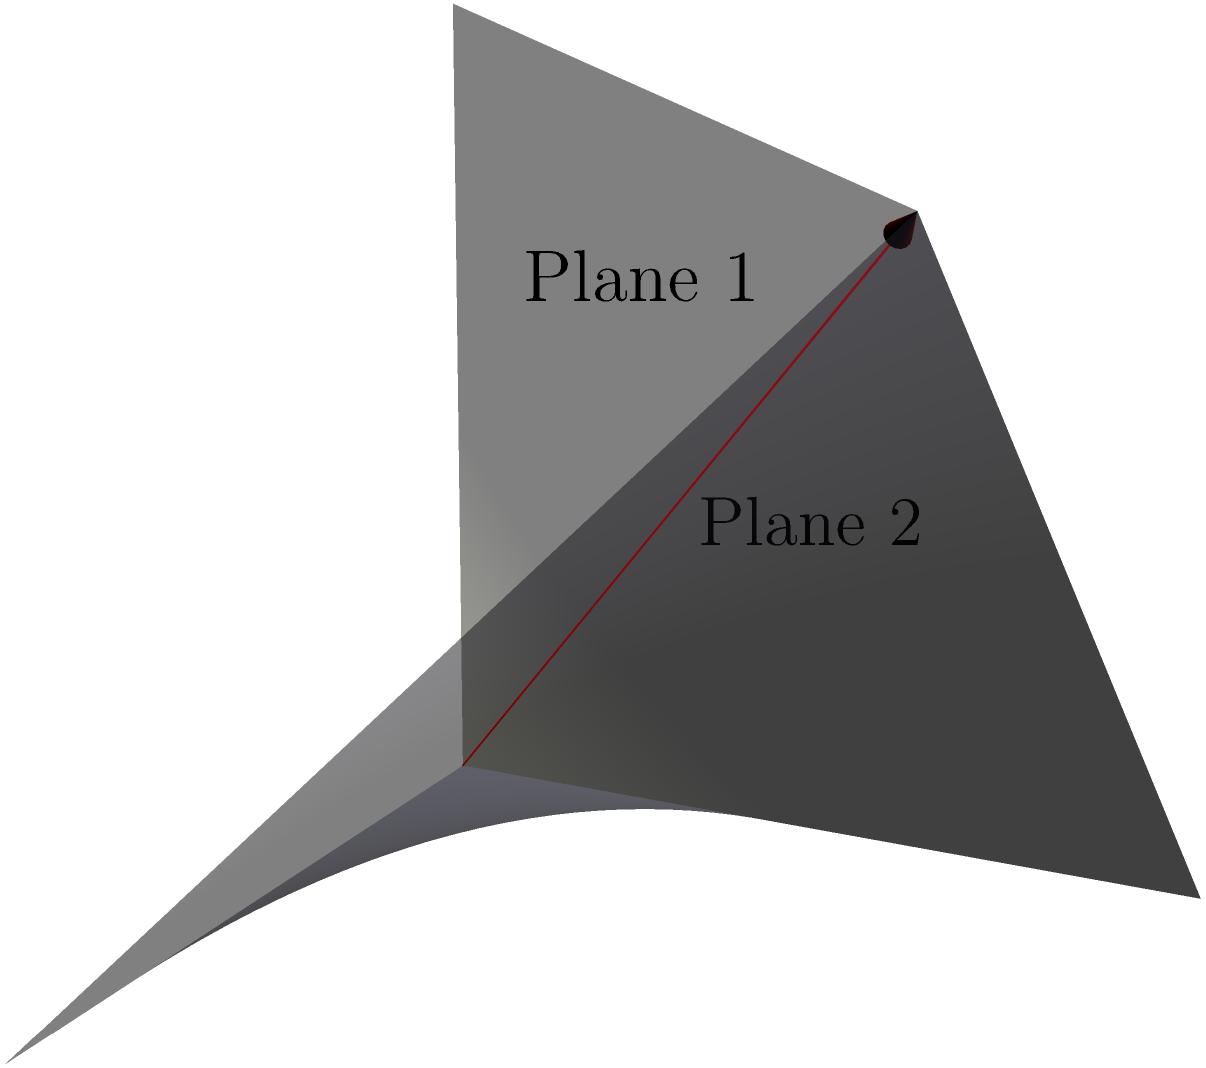In a medieval dragon's wing design, two intersecting planes form the basic structure. If the normal vectors of these planes are $\mathbf{n}_1 = (1, 1, -1)$ and $\mathbf{n}_2 = (1, -1, 1)$, what is the acute angle $\theta$ between these planes? To find the angle between two planes, we can use the dot product of their normal vectors. The formula is:

$$\cos \theta = \frac{|\mathbf{n}_1 \cdot \mathbf{n}_2|}{|\mathbf{n}_1| |\mathbf{n}_2|}$$

Step 1: Calculate the dot product $\mathbf{n}_1 \cdot \mathbf{n}_2$
$\mathbf{n}_1 \cdot \mathbf{n}_2 = (1)(1) + (1)(-1) + (-1)(1) = 1 - 1 - 1 = -1$

Step 2: Calculate the magnitudes of the normal vectors
$|\mathbf{n}_1| = \sqrt{1^2 + 1^2 + (-1)^2} = \sqrt{3}$
$|\mathbf{n}_2| = \sqrt{1^2 + (-1)^2 + 1^2} = \sqrt{3}$

Step 3: Apply the formula
$$\cos \theta = \frac{|-1|}{\sqrt{3} \sqrt{3}} = \frac{1}{3}$$

Step 4: Take the inverse cosine (arccos) of both sides
$$\theta = \arccos(\frac{1}{3})$$

Step 5: Calculate the result
$\theta \approx 70.53°$
Answer: $70.53°$ 